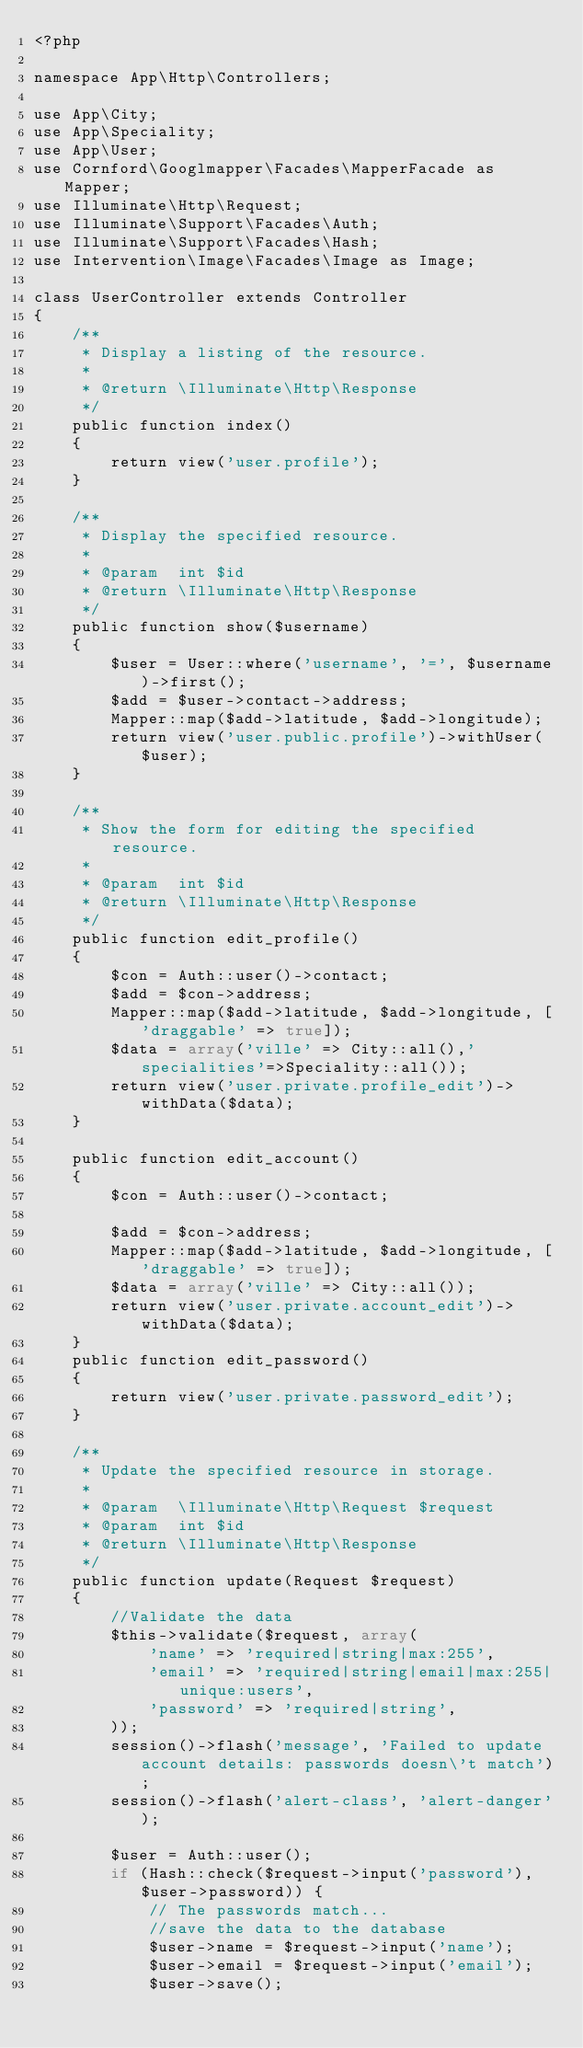<code> <loc_0><loc_0><loc_500><loc_500><_PHP_><?php

namespace App\Http\Controllers;

use App\City;
use App\Speciality;
use App\User;
use Cornford\Googlmapper\Facades\MapperFacade as Mapper;
use Illuminate\Http\Request;
use Illuminate\Support\Facades\Auth;
use Illuminate\Support\Facades\Hash;
use Intervention\Image\Facades\Image as Image;

class UserController extends Controller
{
    /**
     * Display a listing of the resource.
     *
     * @return \Illuminate\Http\Response
     */
    public function index()
    {
        return view('user.profile');
    }

    /**
     * Display the specified resource.
     *
     * @param  int $id
     * @return \Illuminate\Http\Response
     */
    public function show($username)
    {
        $user = User::where('username', '=', $username)->first();
        $add = $user->contact->address;
        Mapper::map($add->latitude, $add->longitude);
        return view('user.public.profile')->withUser($user);
    }

    /**
     * Show the form for editing the specified resource.
     *
     * @param  int $id
     * @return \Illuminate\Http\Response
     */
    public function edit_profile()
    {
        $con = Auth::user()->contact;
        $add = $con->address;
        Mapper::map($add->latitude, $add->longitude, ['draggable' => true]);
        $data = array('ville' => City::all(),'specialities'=>Speciality::all());
        return view('user.private.profile_edit')->withData($data);
    }

    public function edit_account()
    {
        $con = Auth::user()->contact;

        $add = $con->address;
        Mapper::map($add->latitude, $add->longitude, ['draggable' => true]);
        $data = array('ville' => City::all());
        return view('user.private.account_edit')->withData($data);
    }
    public function edit_password()
    {
        return view('user.private.password_edit');
    }

    /**
     * Update the specified resource in storage.
     *
     * @param  \Illuminate\Http\Request $request
     * @param  int $id
     * @return \Illuminate\Http\Response
     */
    public function update(Request $request)
    {
        //Validate the data
        $this->validate($request, array(
            'name' => 'required|string|max:255',
            'email' => 'required|string|email|max:255|unique:users',
            'password' => 'required|string',
        ));
        session()->flash('message', 'Failed to update account details: passwords doesn\'t match');
        session()->flash('alert-class', 'alert-danger');

        $user = Auth::user();
        if (Hash::check($request->input('password'), $user->password)) {
            // The passwords match...
            //save the data to the database
            $user->name = $request->input('name');
            $user->email = $request->input('email');
            $user->save();</code> 